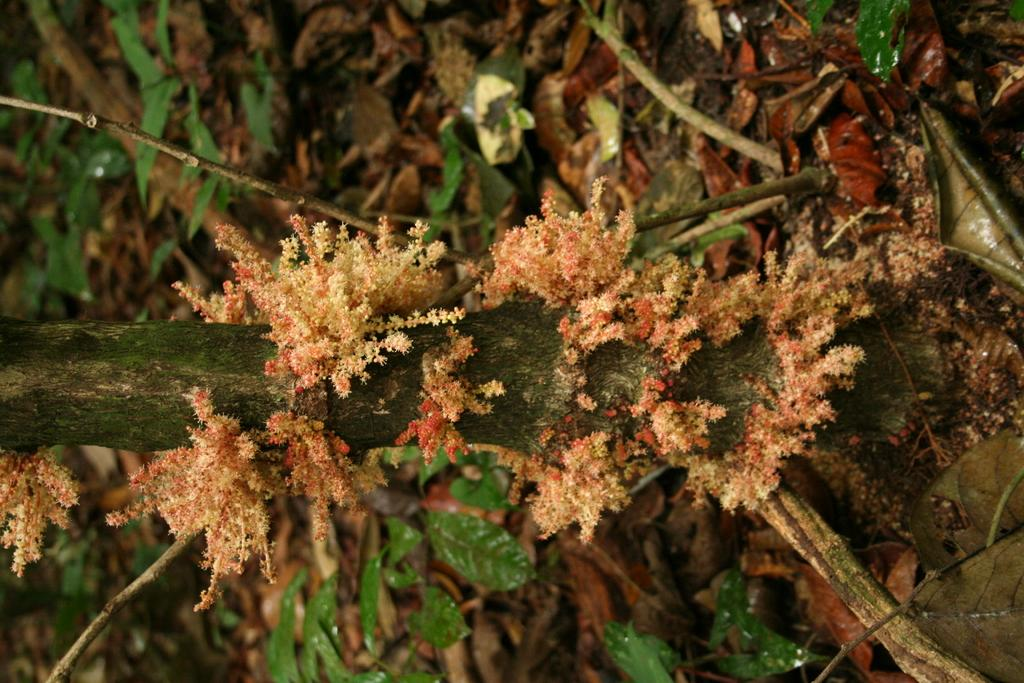What type of vegetation can be seen on the tree branch in the image? There is moss on a branch of a tree in the image. What else can be found near the branch in the image? There are dried leaves beside the branch in the image. Can you see a glove touching the moss on the tree branch in the image? There is no glove or any indication of touch in the image; it only shows moss on a branch and dried leaves beside it. 